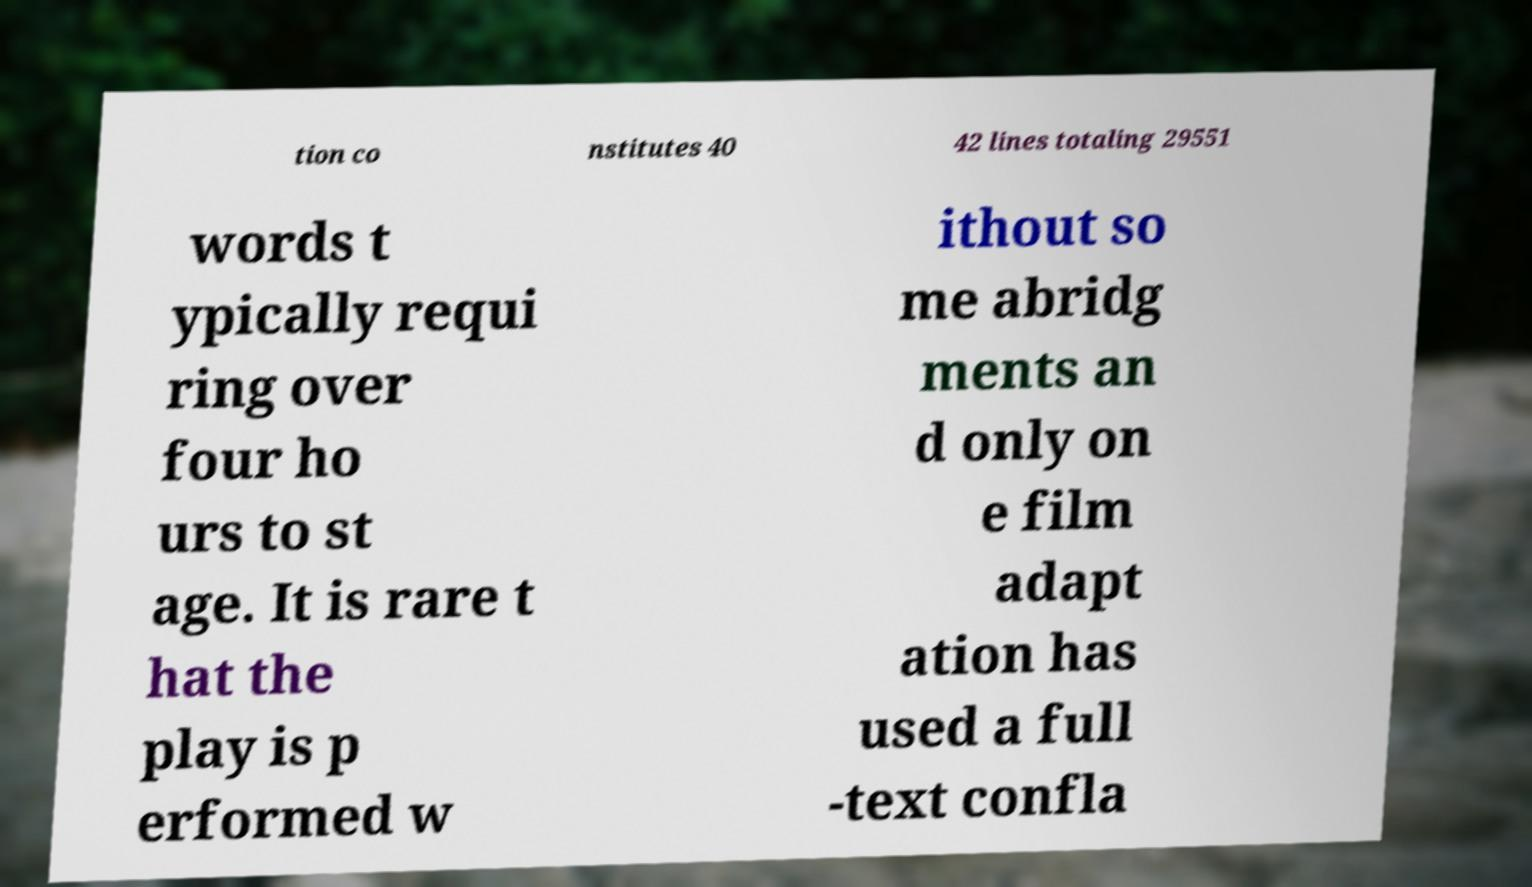Please read and relay the text visible in this image. What does it say? tion co nstitutes 40 42 lines totaling 29551 words t ypically requi ring over four ho urs to st age. It is rare t hat the play is p erformed w ithout so me abridg ments an d only on e film adapt ation has used a full -text confla 